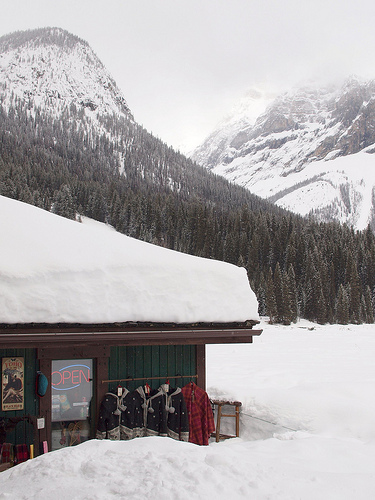<image>
Is the snow on the roof? Yes. Looking at the image, I can see the snow is positioned on top of the roof, with the roof providing support. 